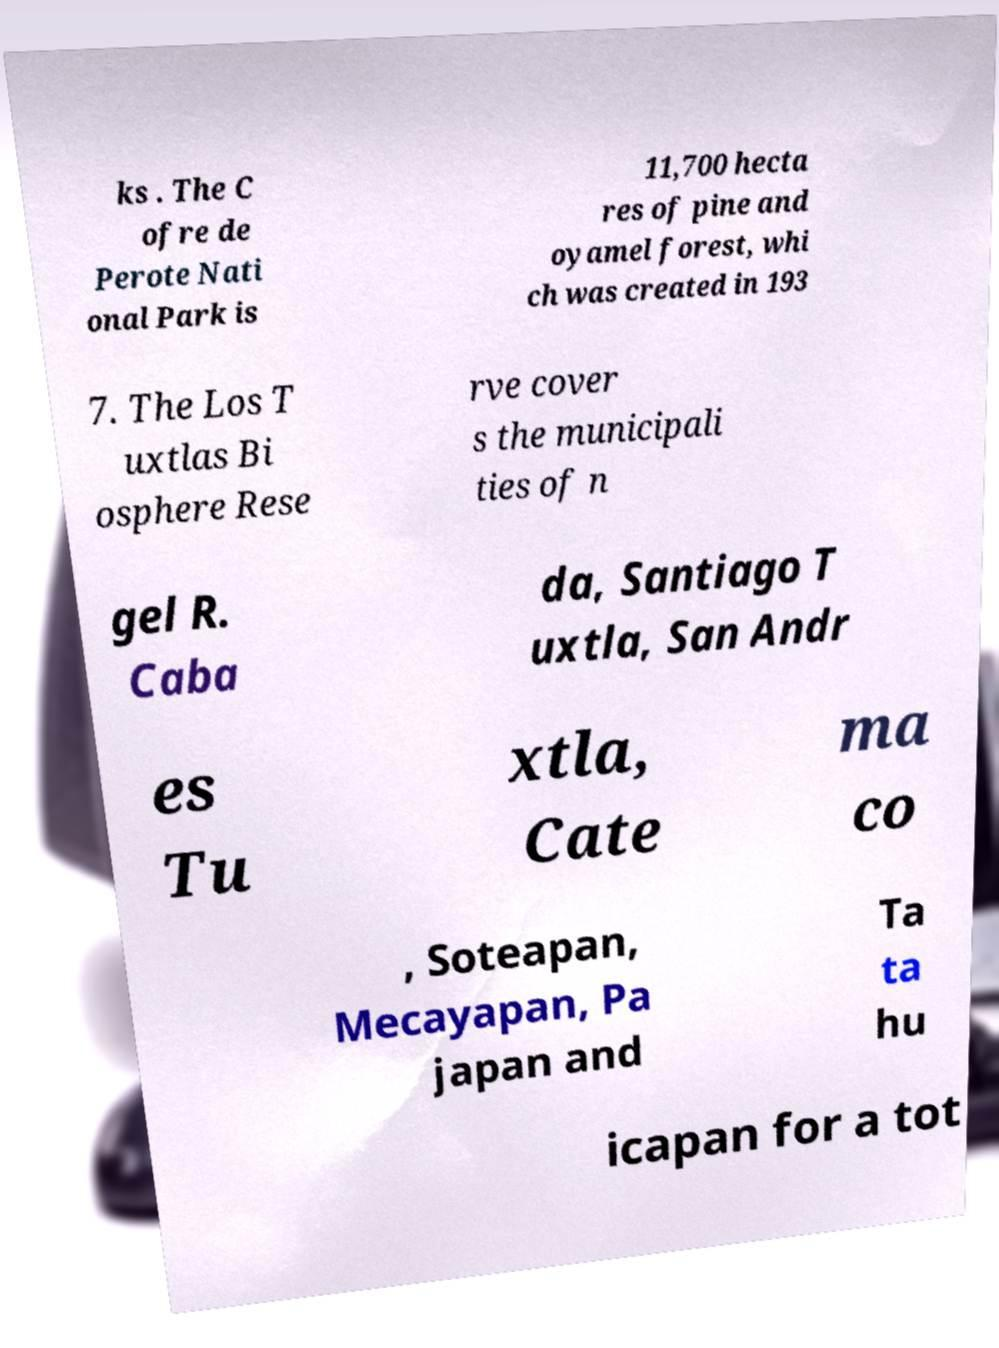Please identify and transcribe the text found in this image. ks . The C ofre de Perote Nati onal Park is 11,700 hecta res of pine and oyamel forest, whi ch was created in 193 7. The Los T uxtlas Bi osphere Rese rve cover s the municipali ties of n gel R. Caba da, Santiago T uxtla, San Andr es Tu xtla, Cate ma co , Soteapan, Mecayapan, Pa japan and Ta ta hu icapan for a tot 